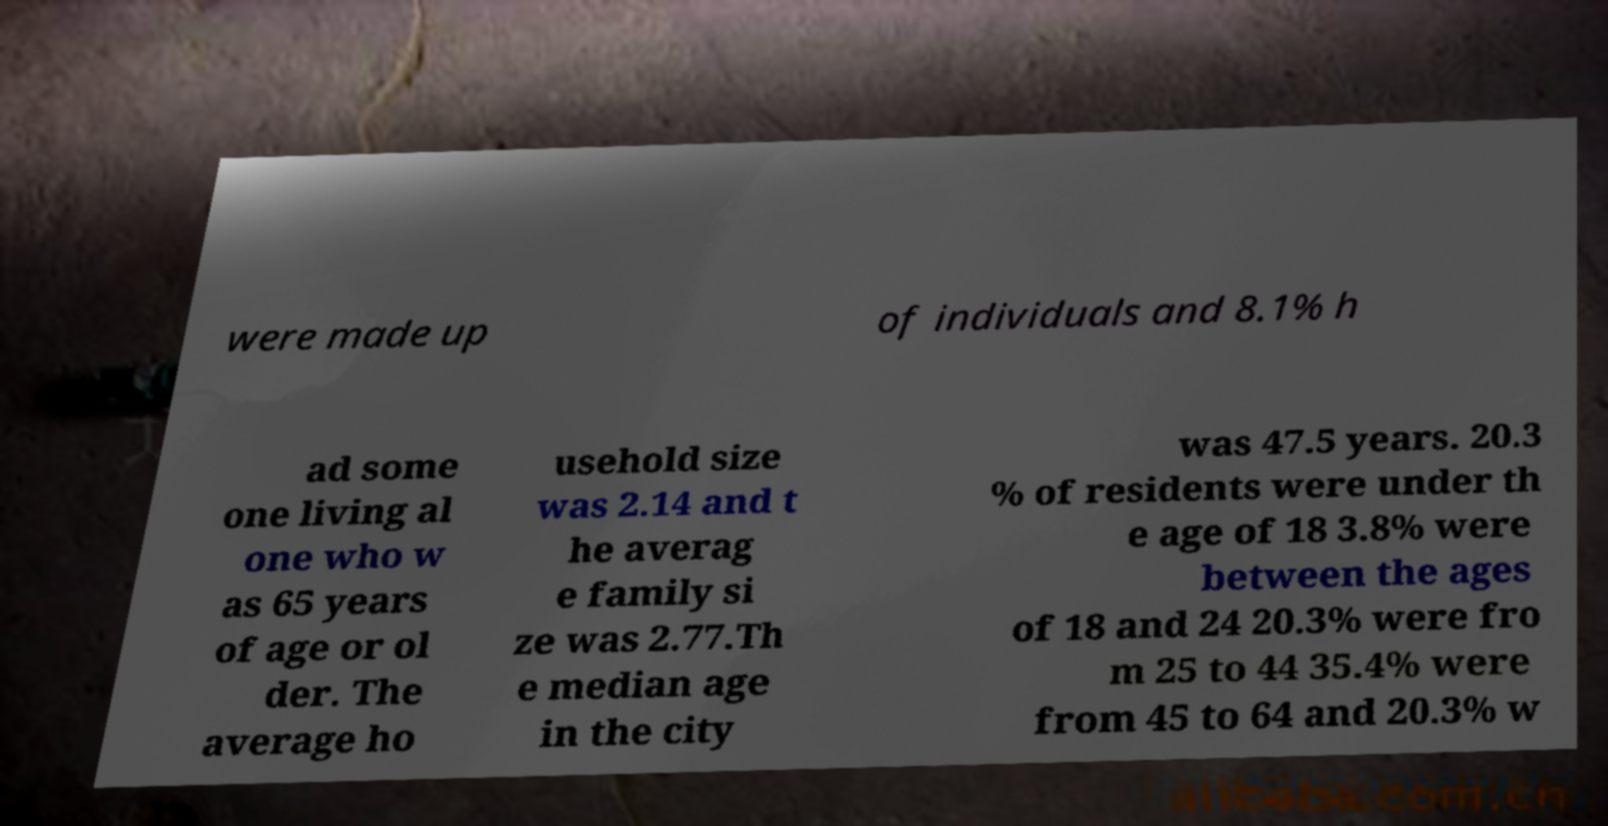For documentation purposes, I need the text within this image transcribed. Could you provide that? were made up of individuals and 8.1% h ad some one living al one who w as 65 years of age or ol der. The average ho usehold size was 2.14 and t he averag e family si ze was 2.77.Th e median age in the city was 47.5 years. 20.3 % of residents were under th e age of 18 3.8% were between the ages of 18 and 24 20.3% were fro m 25 to 44 35.4% were from 45 to 64 and 20.3% w 